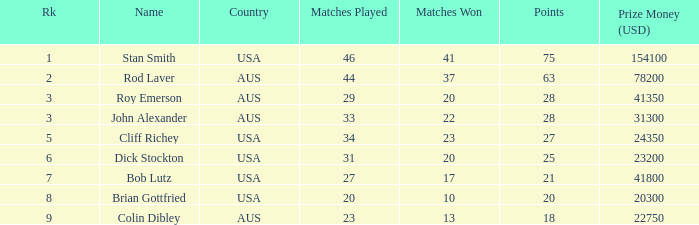How many matches did colin dibley win 13.0. Parse the full table. {'header': ['Rk', 'Name', 'Country', 'Matches Played', 'Matches Won', 'Points', 'Prize Money (USD)'], 'rows': [['1', 'Stan Smith', 'USA', '46', '41', '75', '154100'], ['2', 'Rod Laver', 'AUS', '44', '37', '63', '78200'], ['3', 'Roy Emerson', 'AUS', '29', '20', '28', '41350'], ['3', 'John Alexander', 'AUS', '33', '22', '28', '31300'], ['5', 'Cliff Richey', 'USA', '34', '23', '27', '24350'], ['6', 'Dick Stockton', 'USA', '31', '20', '25', '23200'], ['7', 'Bob Lutz', 'USA', '27', '17', '21', '41800'], ['8', 'Brian Gottfried', 'USA', '20', '10', '20', '20300'], ['9', 'Colin Dibley', 'AUS', '23', '13', '18', '22750']]} 